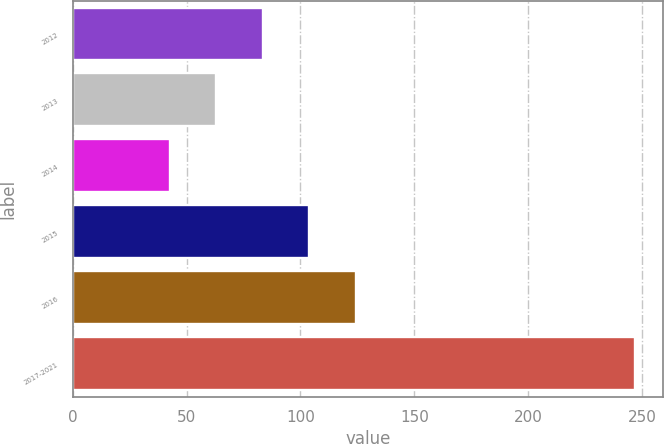Convert chart to OTSL. <chart><loc_0><loc_0><loc_500><loc_500><bar_chart><fcel>2012<fcel>2013<fcel>2014<fcel>2015<fcel>2016<fcel>2017-2021<nl><fcel>83.5<fcel>63.1<fcel>42.7<fcel>103.9<fcel>124.3<fcel>246.7<nl></chart> 